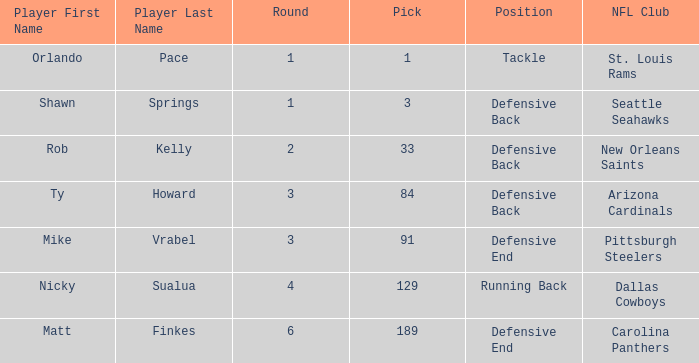What player has defensive back as the position, with a round less than 2? Shawn Springs. 